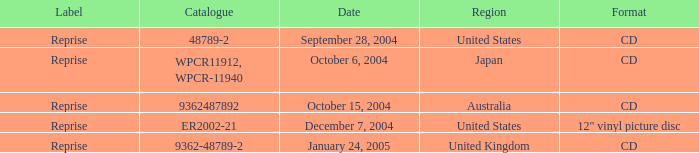Name the catalogue for australia 9362487892.0. 